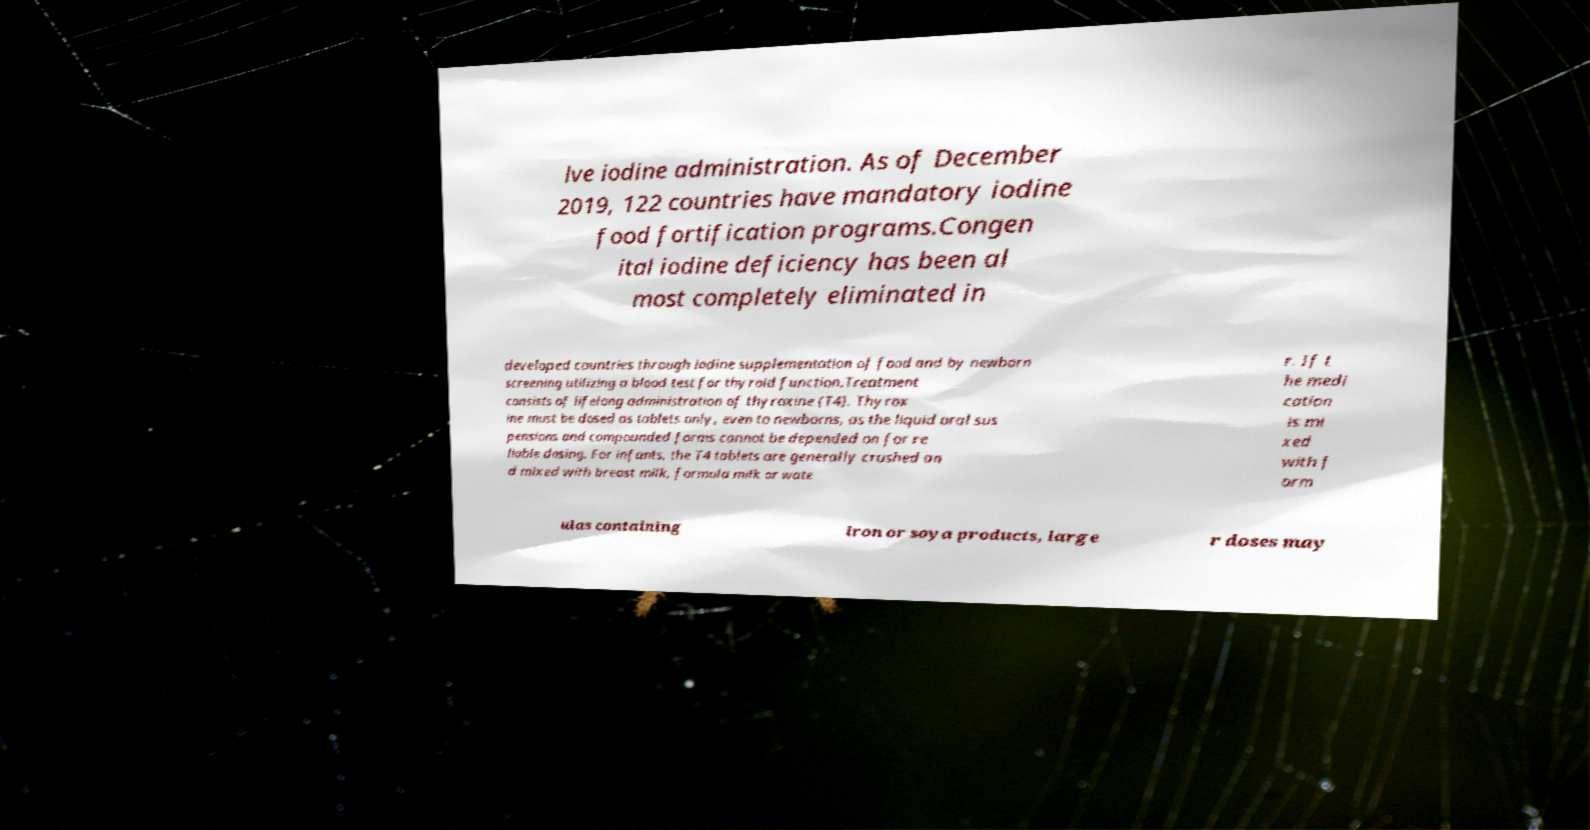For documentation purposes, I need the text within this image transcribed. Could you provide that? lve iodine administration. As of December 2019, 122 countries have mandatory iodine food fortification programs.Congen ital iodine deficiency has been al most completely eliminated in developed countries through iodine supplementation of food and by newborn screening utilizing a blood test for thyroid function.Treatment consists of lifelong administration of thyroxine (T4). Thyrox ine must be dosed as tablets only, even to newborns, as the liquid oral sus pensions and compounded forms cannot be depended on for re liable dosing. For infants, the T4 tablets are generally crushed an d mixed with breast milk, formula milk or wate r. If t he medi cation is mi xed with f orm ulas containing iron or soya products, large r doses may 